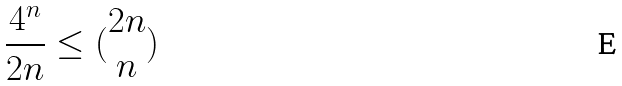Convert formula to latex. <formula><loc_0><loc_0><loc_500><loc_500>\frac { 4 ^ { n } } { 2 n } \leq ( \begin{matrix} 2 n \\ n \end{matrix} )</formula> 